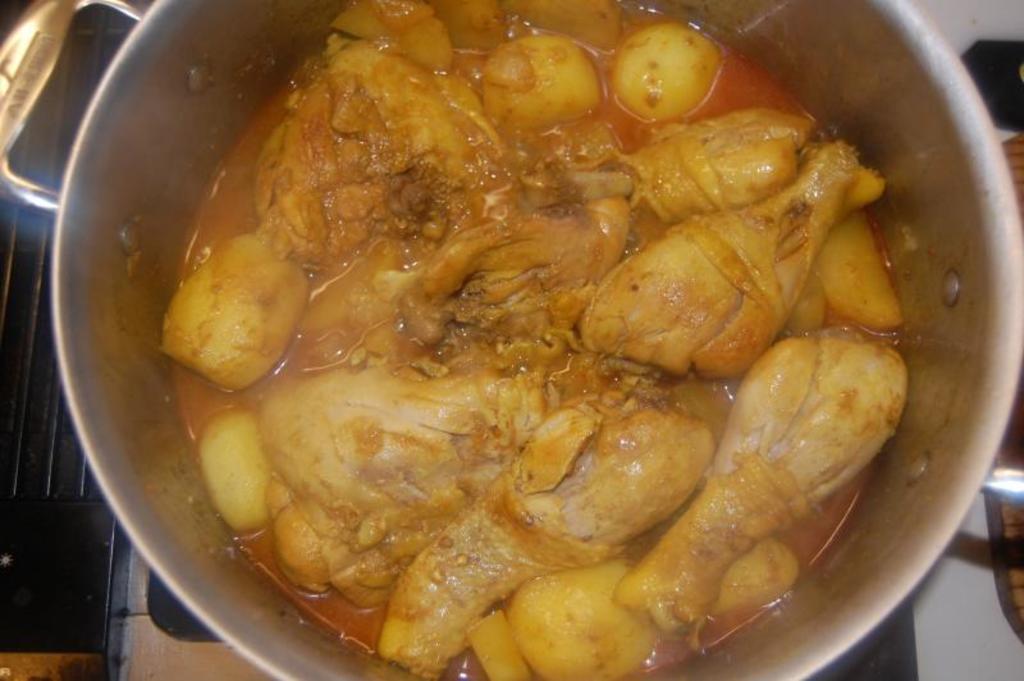How would you summarize this image in a sentence or two? In this image inside a vessel there is chicken curry with potato. This is the stove. 